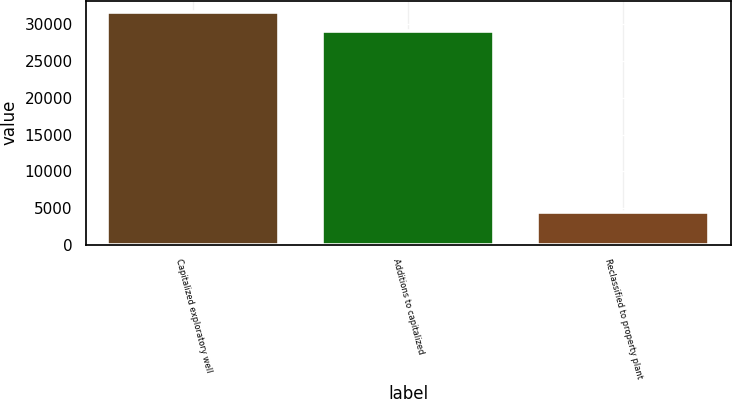<chart> <loc_0><loc_0><loc_500><loc_500><bar_chart><fcel>Capitalized exploratory well<fcel>Additions to capitalized<fcel>Reclassified to property plant<nl><fcel>31678<fcel>29092<fcel>4377<nl></chart> 